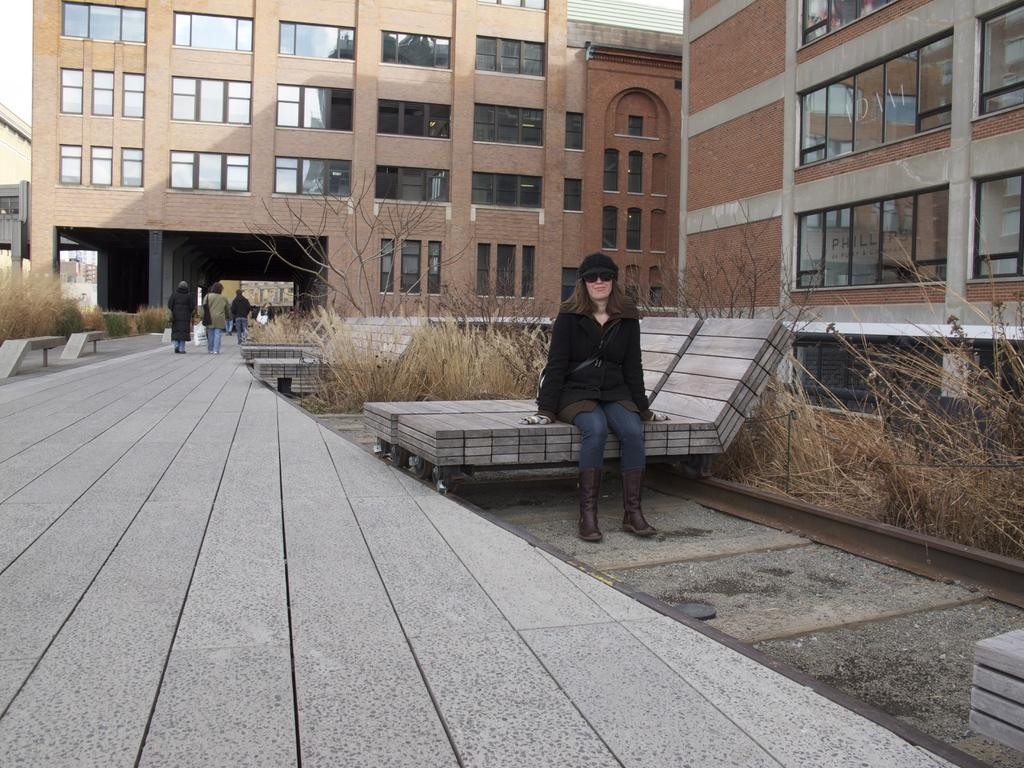What is the woman in the image doing? The woman is sitting on a bench in the image. What accessories is the woman wearing? The woman is wearing a hat and glasses. What can be seen in the background of the image? There is grass, a tree, a building, and the sky visible in the background of the image. Additionally, there are people walking in the background. What type of lift is the woman using to reach the top of the tree in the image? There is no lift present in the image, and the woman is not depicted as climbing or interacting with the tree. 